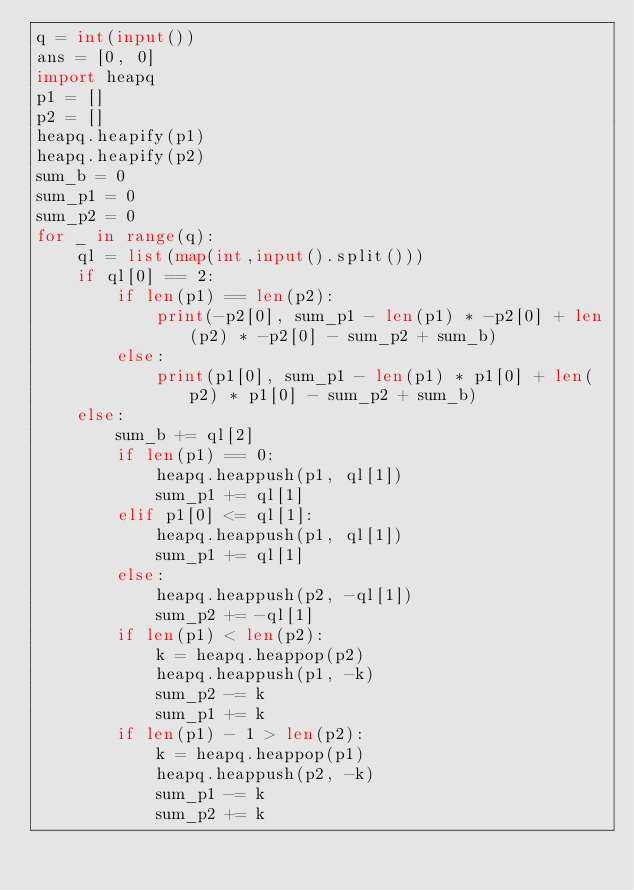Convert code to text. <code><loc_0><loc_0><loc_500><loc_500><_Python_>q = int(input())
ans = [0, 0]
import heapq
p1 = []
p2 = []
heapq.heapify(p1)
heapq.heapify(p2)
sum_b = 0
sum_p1 = 0
sum_p2 = 0
for _ in range(q):
    ql = list(map(int,input().split()))
    if ql[0] == 2:
        if len(p1) == len(p2):
            print(-p2[0], sum_p1 - len(p1) * -p2[0] + len(p2) * -p2[0] - sum_p2 + sum_b)
        else:
            print(p1[0], sum_p1 - len(p1) * p1[0] + len(p2) * p1[0] - sum_p2 + sum_b)
    else:
        sum_b += ql[2]
        if len(p1) == 0:
            heapq.heappush(p1, ql[1])
            sum_p1 += ql[1]
        elif p1[0] <= ql[1]:
            heapq.heappush(p1, ql[1])
            sum_p1 += ql[1]
        else:
            heapq.heappush(p2, -ql[1])
            sum_p2 += -ql[1]
        if len(p1) < len(p2):
            k = heapq.heappop(p2)
            heapq.heappush(p1, -k)
            sum_p2 -= k
            sum_p1 += k
        if len(p1) - 1 > len(p2):
            k = heapq.heappop(p1)
            heapq.heappush(p2, -k)
            sum_p1 -= k
            sum_p2 += k

</code> 